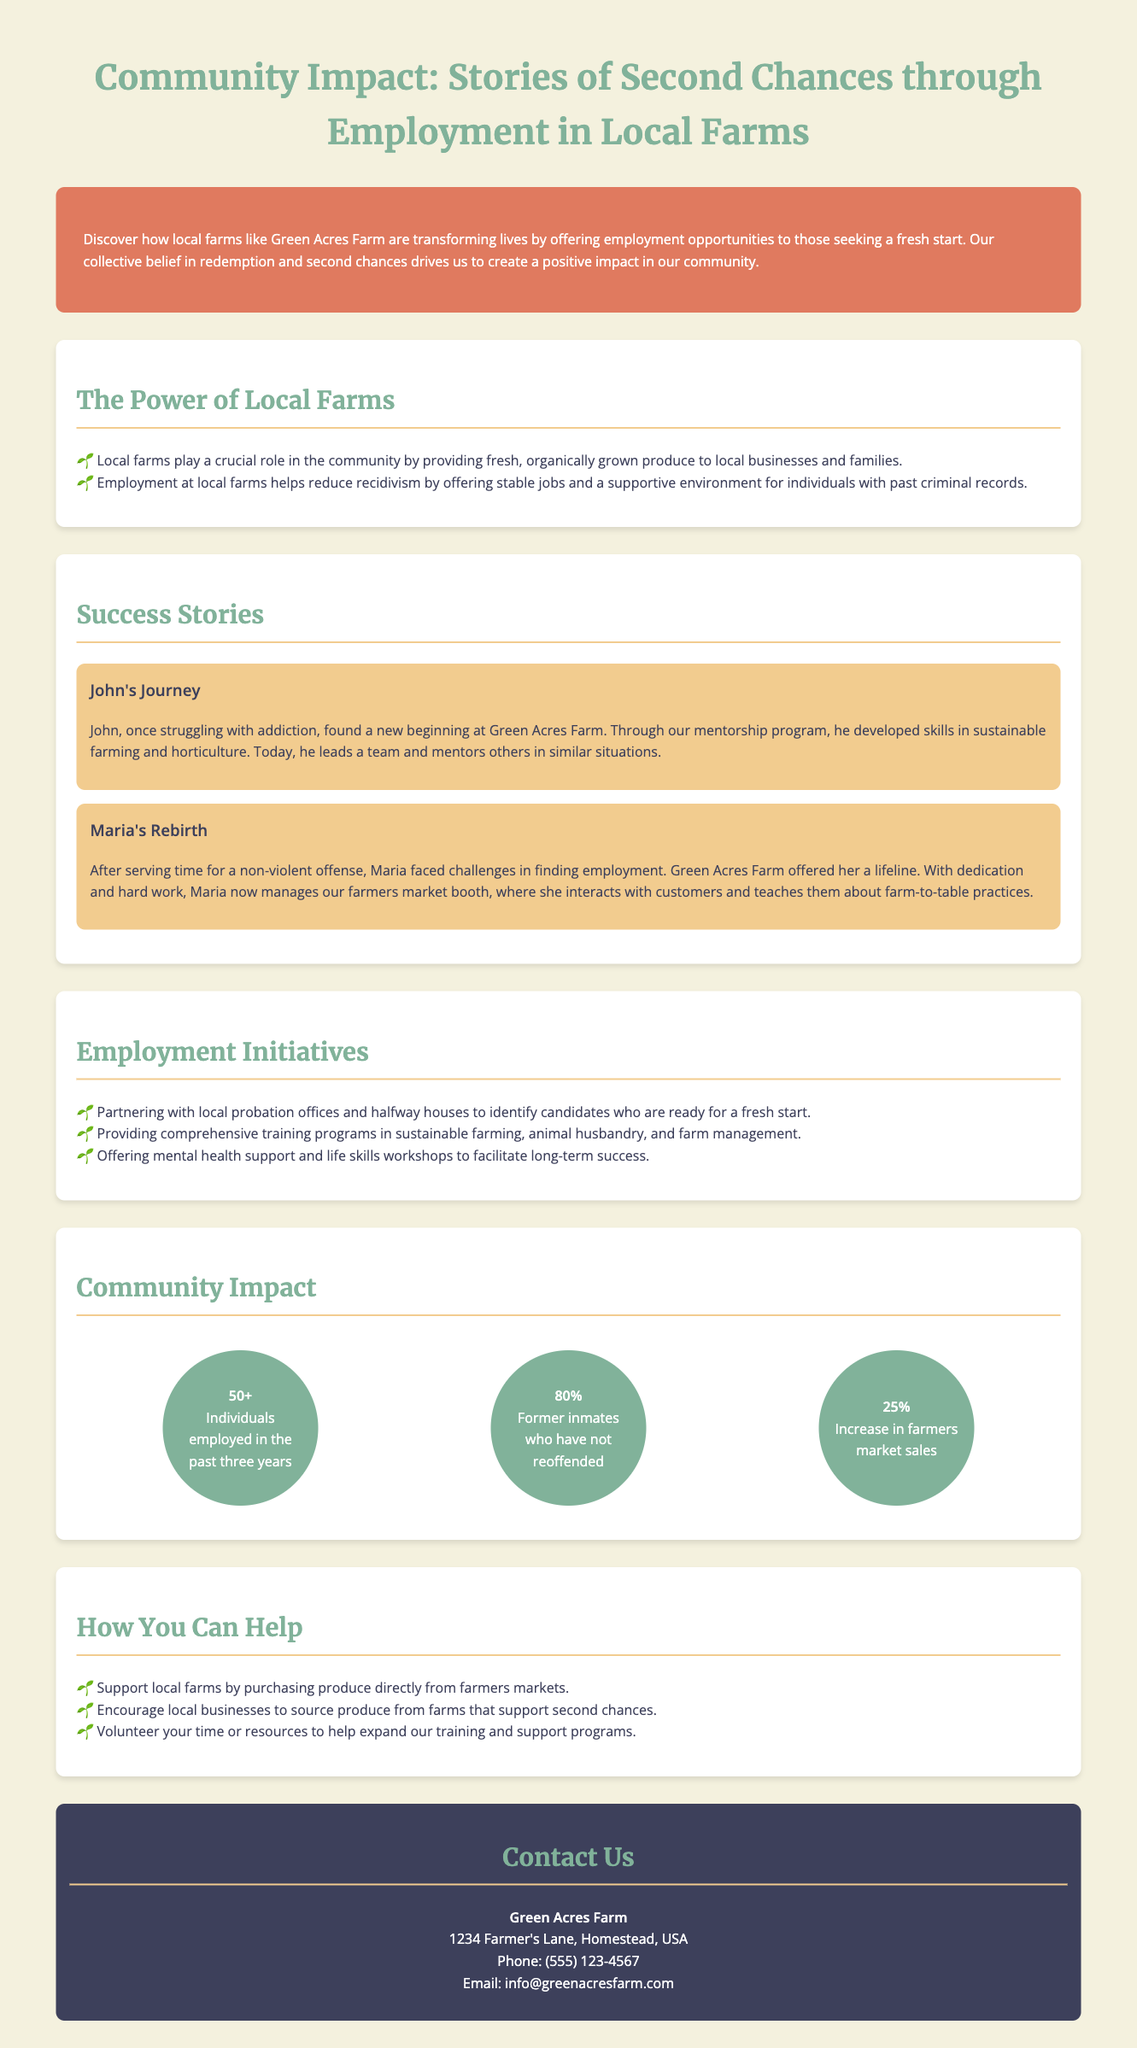What is the name of the farm mentioned in the document? The document refers to the farm as Green Acres Farm.
Answer: Green Acres Farm How many individuals have been employed in the past three years? The document states that more than 50 individuals have been employed in that timeframe.
Answer: 50+ What percentage of former inmates have not reoffended? The document specifies that 80% of former inmates have not reoffended.
Answer: 80% Who is responsible for managing the farmers market booth? The document mentions that Maria now manages the farmers market booth.
Answer: Maria What type of support do the employment initiatives offer? The document states they offer mental health support and life skills workshops.
Answer: Mental health support and life skills workshops What is one way to support local farms mentioned in the document? The document advises purchasing produce directly from farmers markets as a way to support local farms.
Answer: Purchasing produce directly from farmers markets Which program helps individuals like John develop skills in sustainable farming? The document mentions a mentorship program that helps individuals develop these skills.
Answer: Mentorship program What is the increase in farmers market sales? The document reports a 25% increase in farmers market sales.
Answer: 25% 